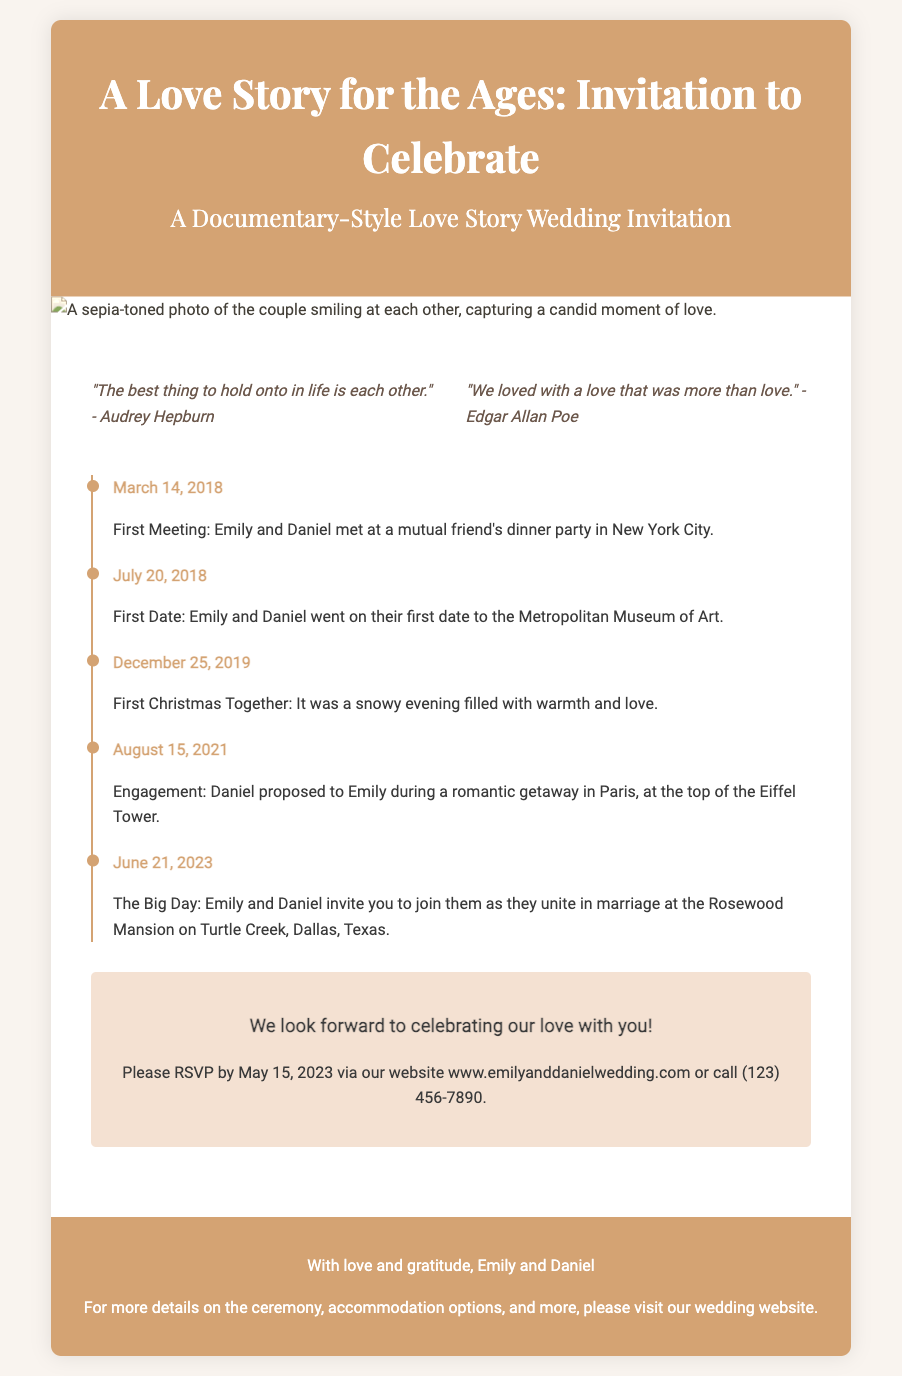What are the names of the couple? The couple's names are mentioned prominently in the title of the invitation.
Answer: Emily and Daniel What date is the wedding taking place? The wedding date is clearly provided in the timeline events section.
Answer: June 21, 2023 Where is the wedding ceremony being held? The location of the wedding is stated in the timeline.
Answer: Rosewood Mansion on Turtle Creek, Dallas, Texas What is the RSVP deadline? The RSVP deadline is specified in the content area of the invitation.
Answer: May 15, 2023 What was the first date of the couple? The timeline provides specific events and their dates, including this one.
Answer: July 20, 2018 Which quote is attributed to Edgar Allan Poe? The invitation includes heartfelt quotes, one of which is from Edgar Allan Poe.
Answer: "We loved with a love that was more than love." What event happened on December 25, 2019? The timeline outlines significant moments in the couple's relationship with corresponding dates.
Answer: First Christmas Together What style is this wedding invitation designed in? The document describes the style of the invitation in the header section.
Answer: Documentary-Style 